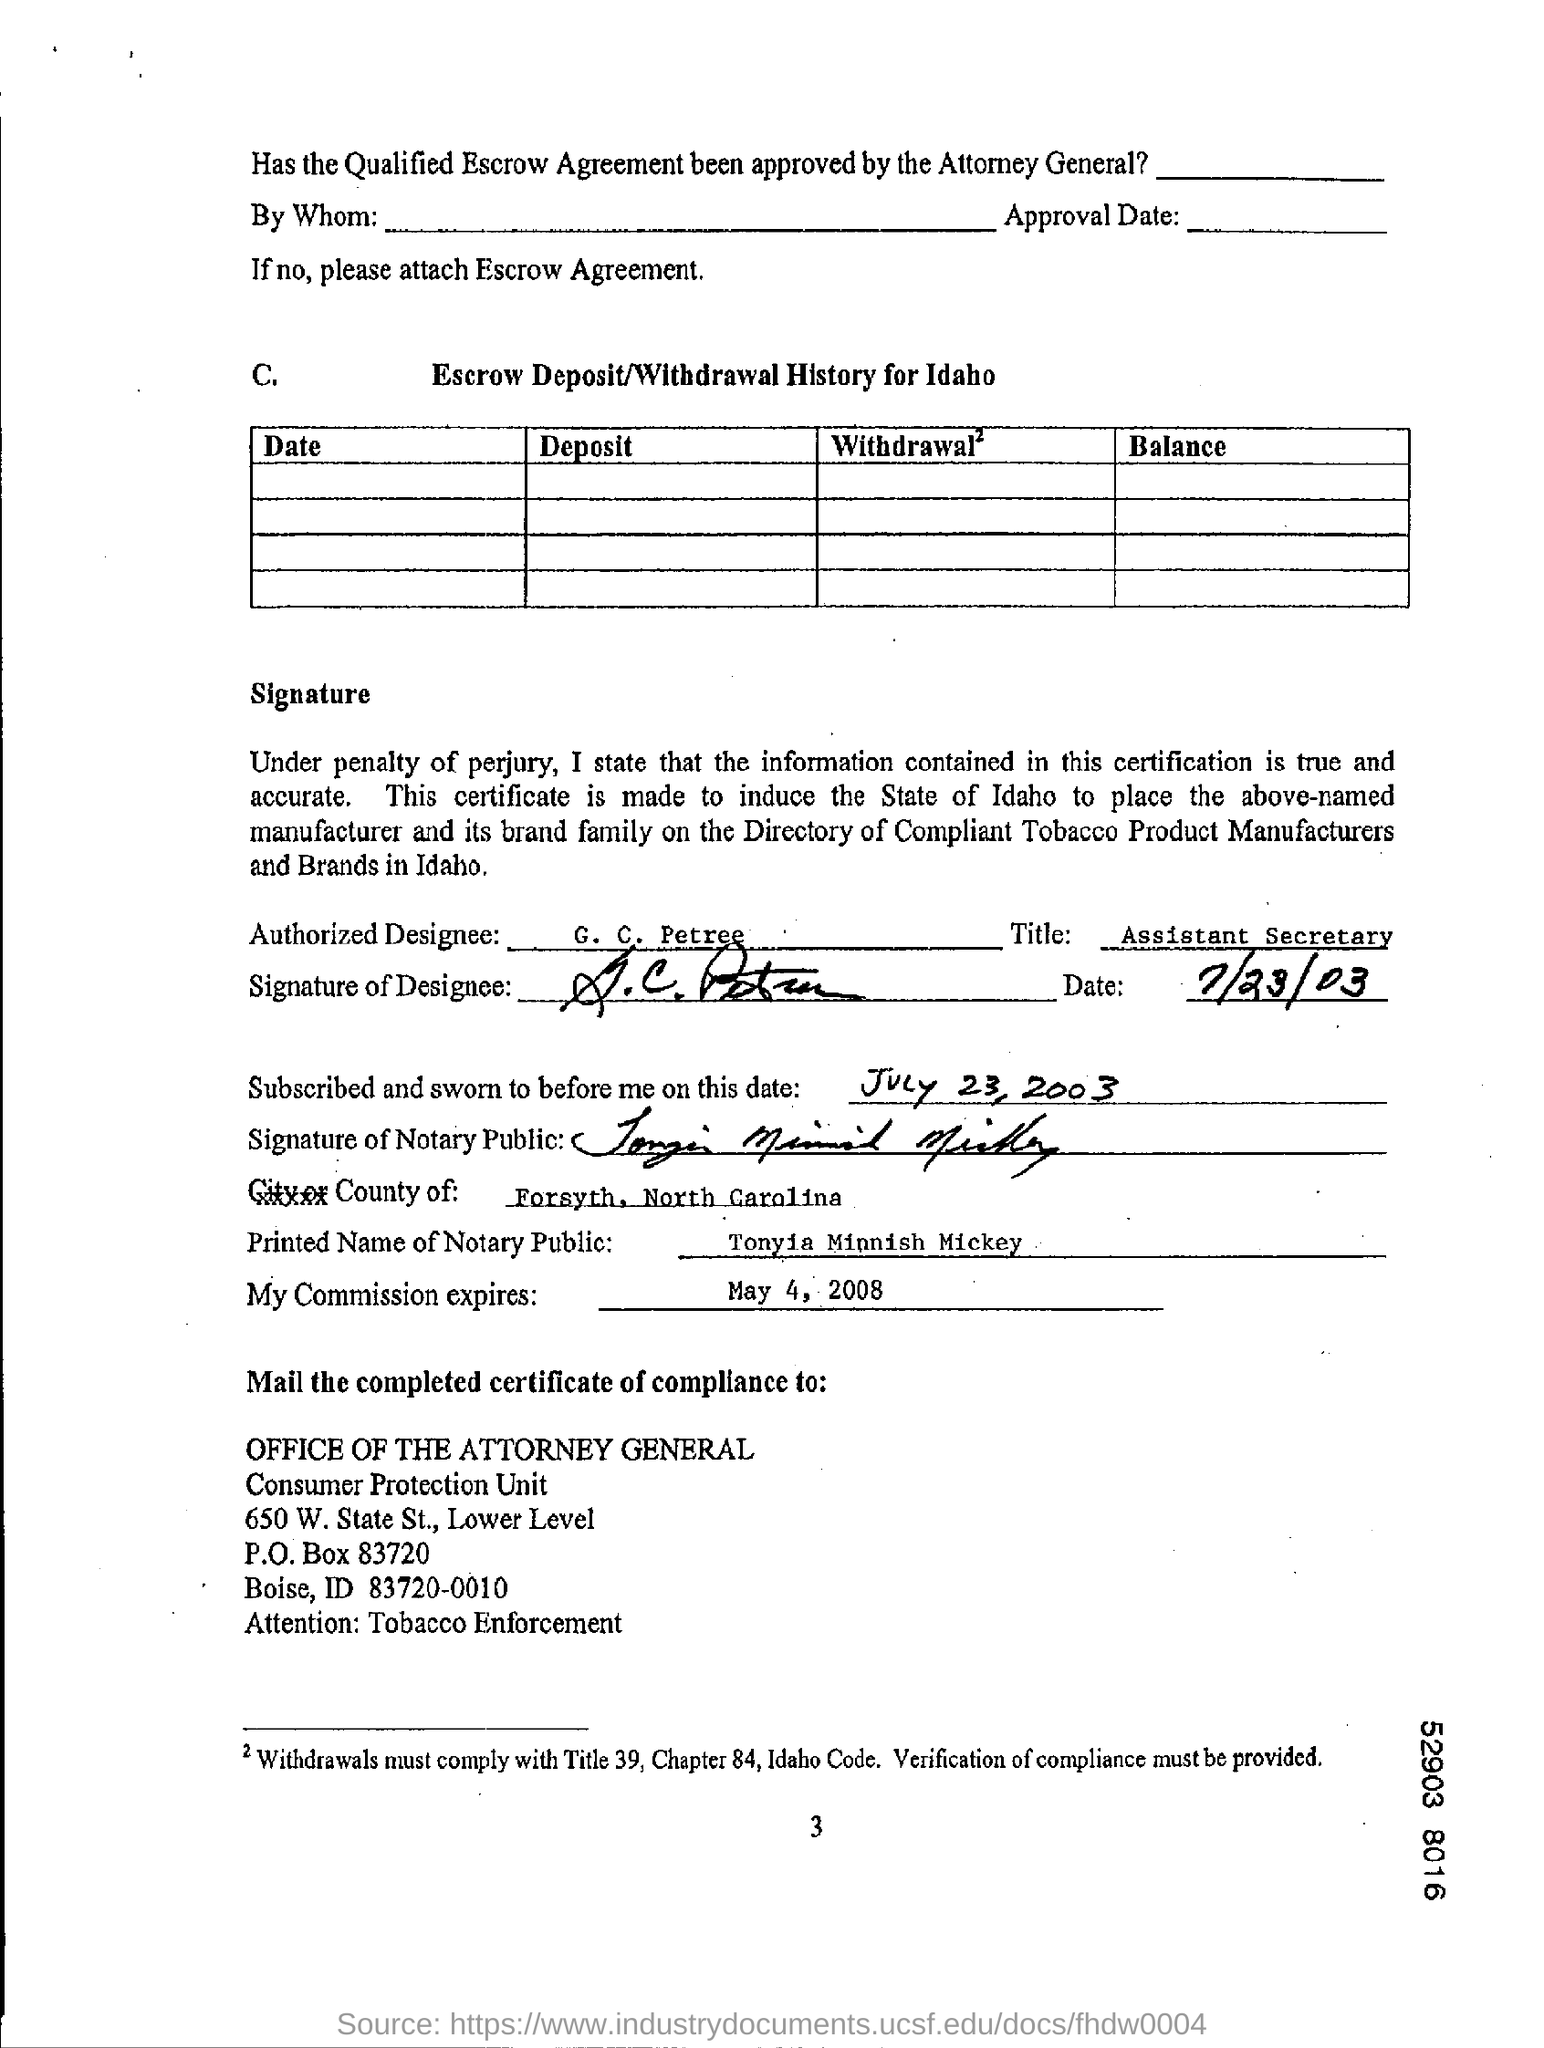Who is the authorized designee?
Ensure brevity in your answer.  G. C. Petree. What is the designation of G.C. Petree?
Your answer should be compact. Assistant Secretary. 